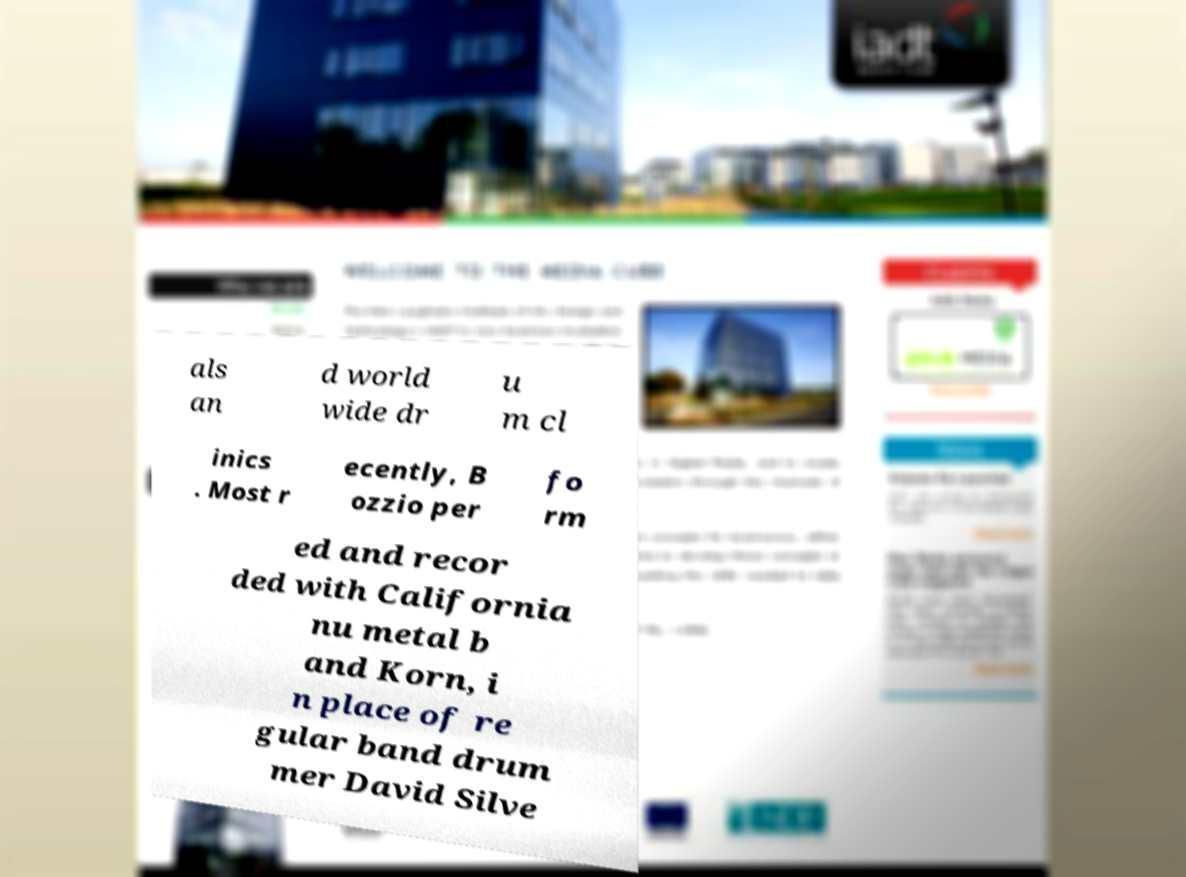Could you extract and type out the text from this image? als an d world wide dr u m cl inics . Most r ecently, B ozzio per fo rm ed and recor ded with California nu metal b and Korn, i n place of re gular band drum mer David Silve 